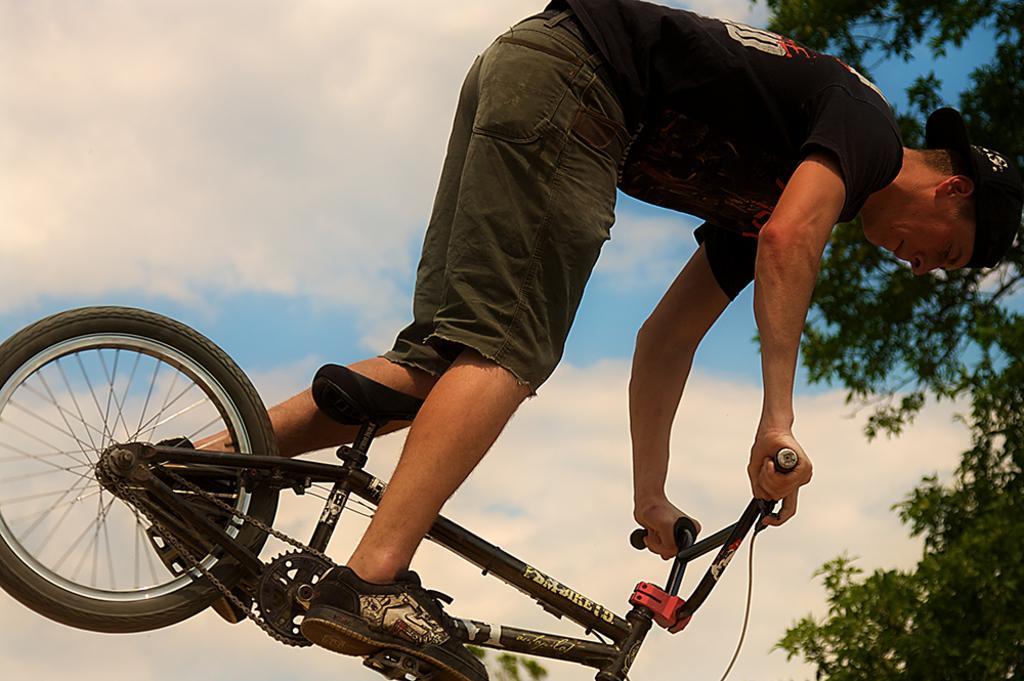In one or two sentences, can you explain what this image depicts? This image is an outside view. In this image a man is riding on a bicycle wearing shoes and a hat. In the left side of the image there is a tire of the bicycle. In the right side of the image there is a tree. At the background there is a sky with clouds. 